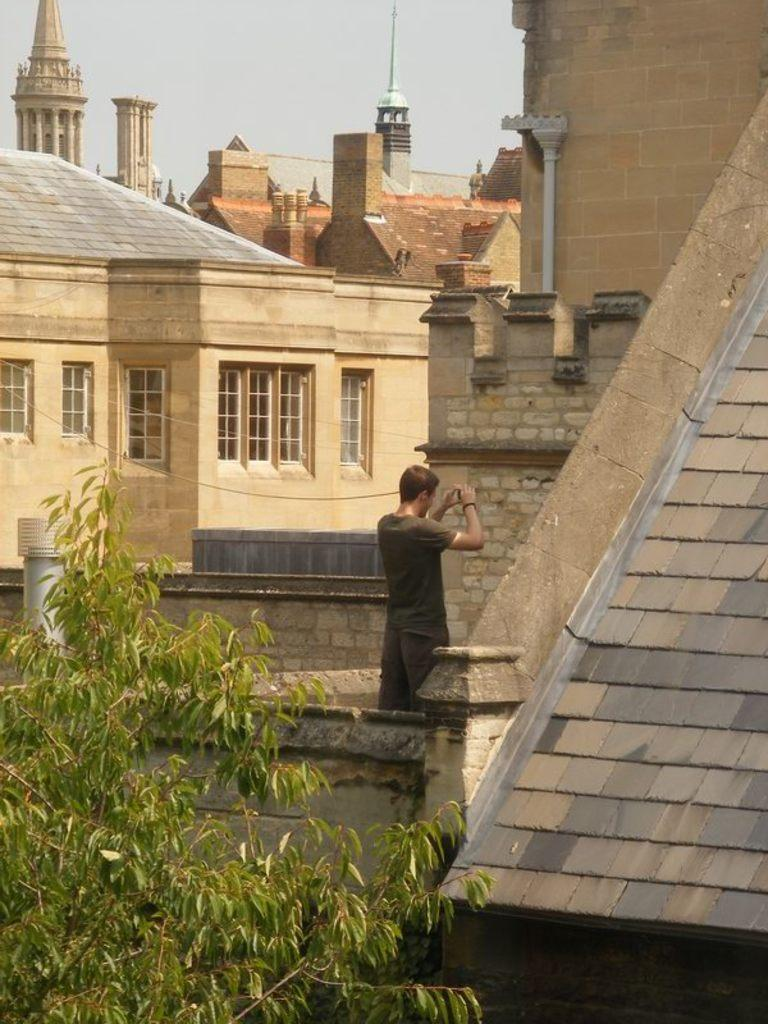What is the main subject in the image? There is a person in the image. What type of structures can be seen in the image? There are buildings with glass doors in the image. What type of vegetation is present in the image? There is a tree in the image. What is visible in the background of the image? The sky is visible in the image. What type of honey is being used to write the prose on the chessboard in the image? There is no honey, prose, or chessboard present in the image. 